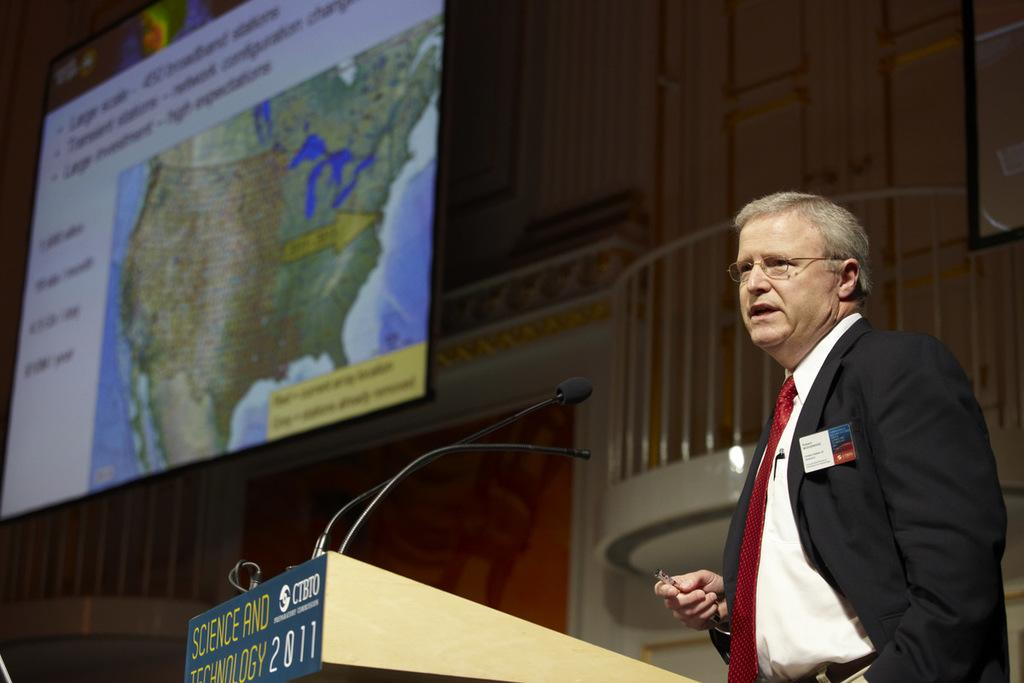What are the persons in the image doing? The persons in the image are standing at the desk. What objects can be seen on the desk? Mics are present on the desk. What is visible in the background of the image? There is a wall and a screen in the background of the image. What type of club can be seen in the image? There is no club present in the image; it features persons standing at a desk with mics and a background with a wall and a screen. Is there any rain visible in the image? There is no rain present in the image. 